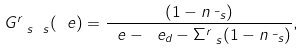<formula> <loc_0><loc_0><loc_500><loc_500>G _ { \ s \ s } ^ { r } ( \ e ) = \frac { ( 1 - n _ { \bar { \ s } } ) } { \ e - \ e _ { d } - \Sigma _ { \ s } ^ { r } ( 1 - n _ { \bar { \ s } } ) } ,</formula> 